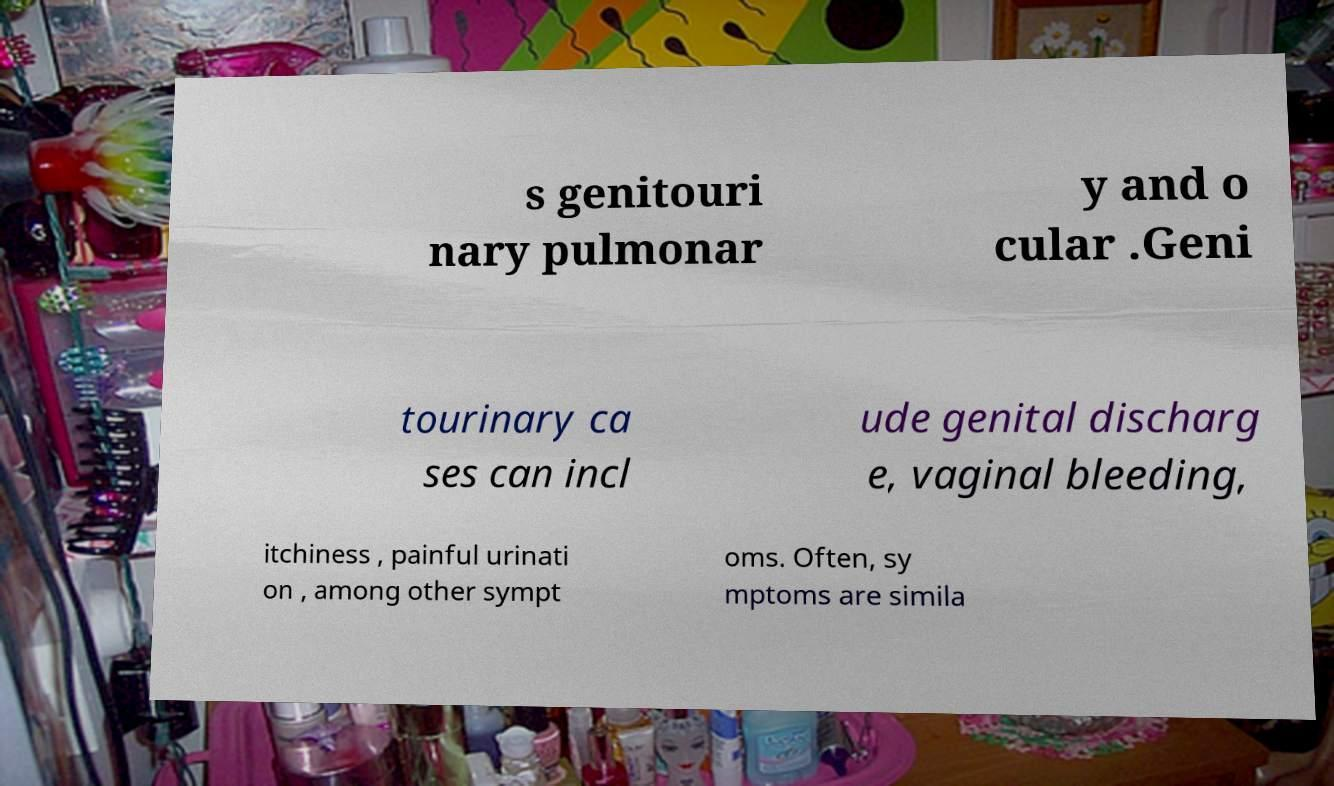Can you read and provide the text displayed in the image?This photo seems to have some interesting text. Can you extract and type it out for me? s genitouri nary pulmonar y and o cular .Geni tourinary ca ses can incl ude genital discharg e, vaginal bleeding, itchiness , painful urinati on , among other sympt oms. Often, sy mptoms are simila 